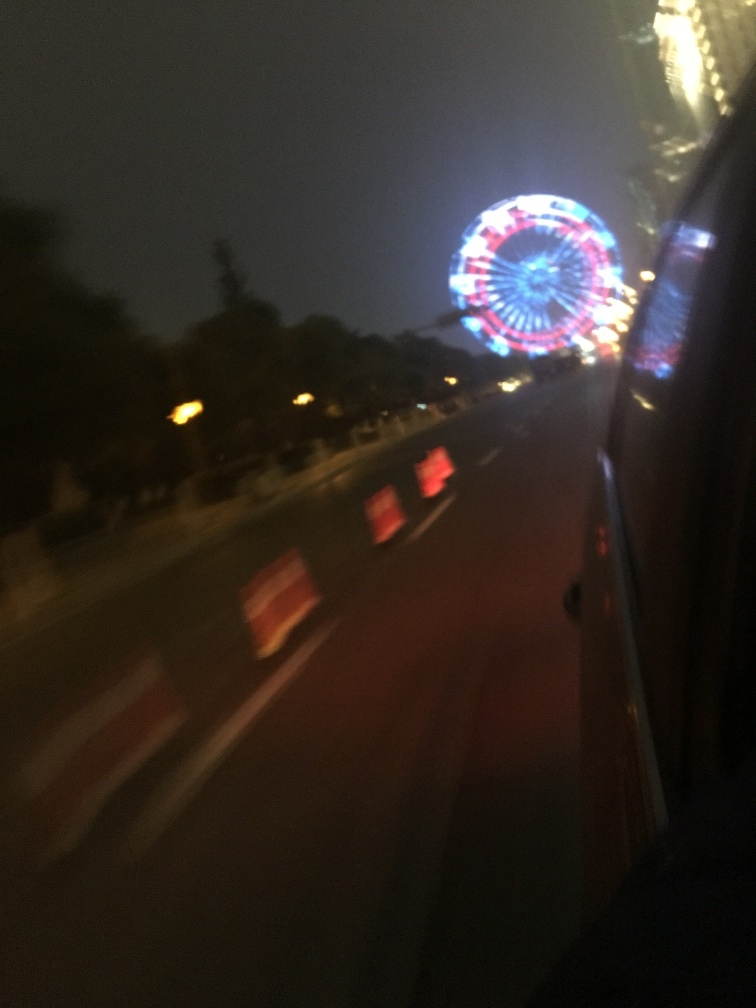Can you tell something about the speed of the vehicle from which this photo was taken? The streaking lights and blurry surroundings suggest that the vehicle from which the photo was taken was moving at a relatively high speed. This effect often results from a combination of motion and longer exposure times used in low-light photography. 